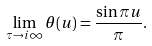<formula> <loc_0><loc_0><loc_500><loc_500>\lim _ { \tau \to i \infty } \theta ( u ) = \frac { \sin \pi u } { \pi } .</formula> 